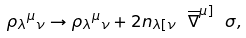<formula> <loc_0><loc_0><loc_500><loc_500>\rho _ { \lambda } { ^ { \mu } } _ { \nu } \rightarrow \rho _ { \lambda } { ^ { \mu } } _ { \nu } + 2 n _ { \lambda [ \nu } \ \overline { \nabla } ^ { \mu ] } \ \sigma ,</formula> 